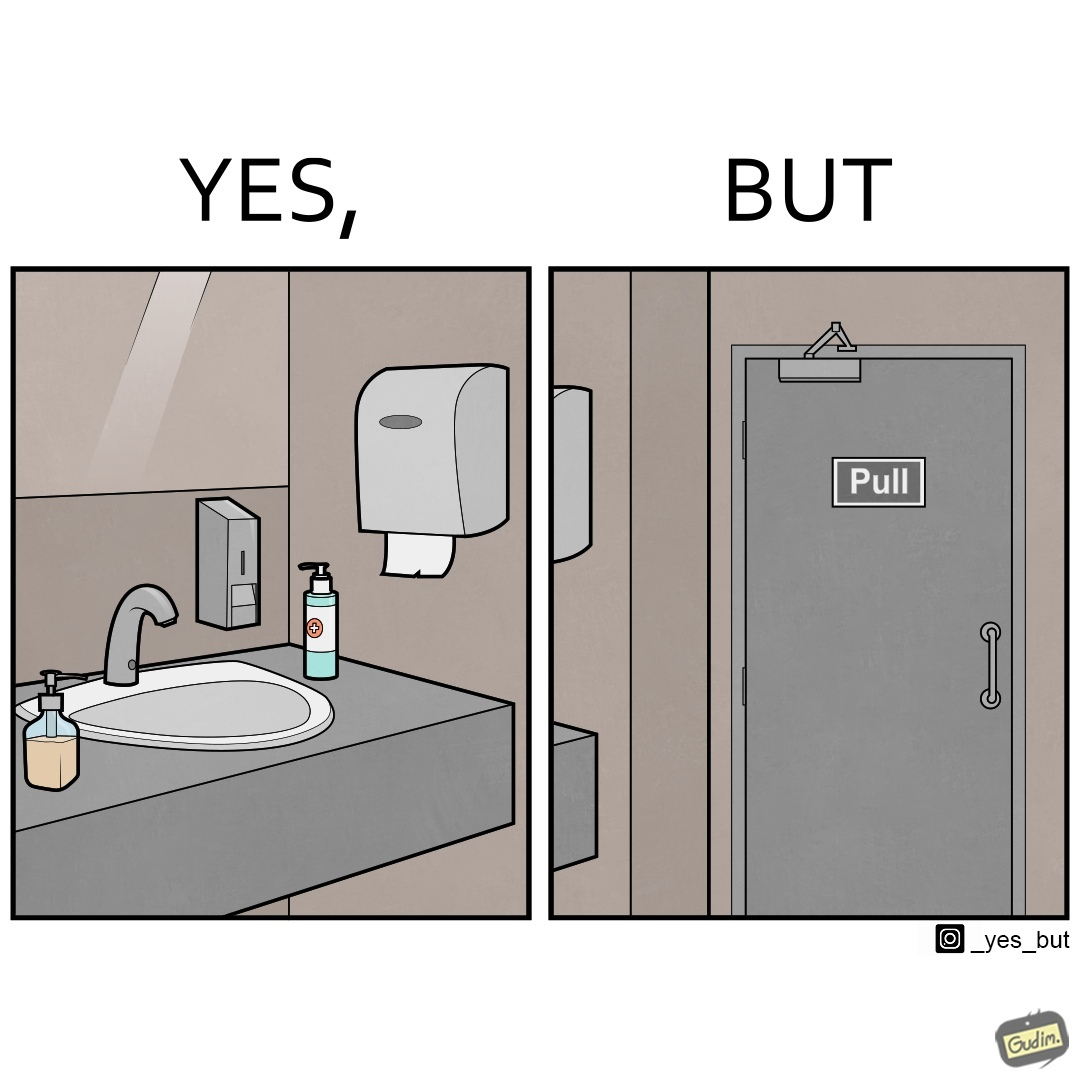Compare the left and right sides of this image. In the left part of the image: a basin with different handwashes and paper roll around it to clean hands with a mirror in front In the right part of the image: a door with a pull sign and handle on it 